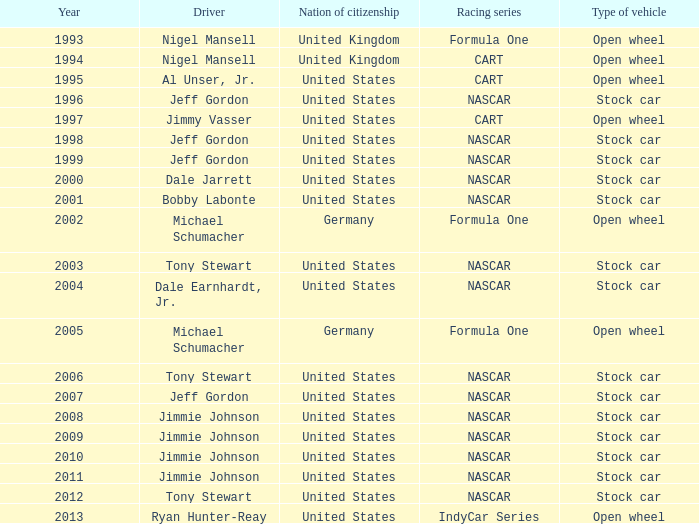Which country of citizenship possesses a stock car automobile from the year 1999? United States. 